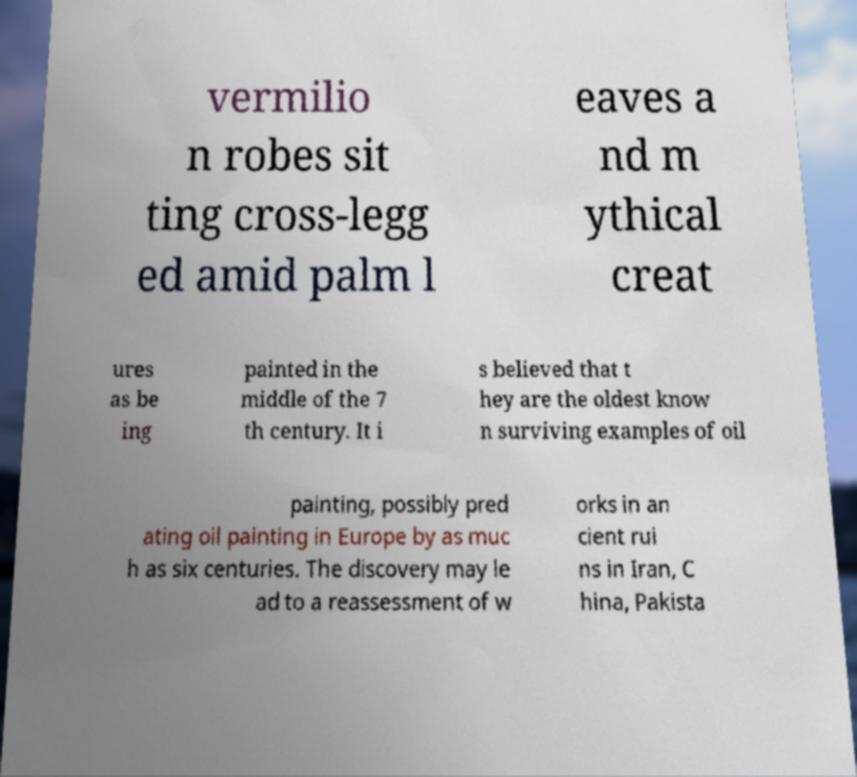Can you read and provide the text displayed in the image?This photo seems to have some interesting text. Can you extract and type it out for me? vermilio n robes sit ting cross-legg ed amid palm l eaves a nd m ythical creat ures as be ing painted in the middle of the 7 th century. It i s believed that t hey are the oldest know n surviving examples of oil painting, possibly pred ating oil painting in Europe by as muc h as six centuries. The discovery may le ad to a reassessment of w orks in an cient rui ns in Iran, C hina, Pakista 